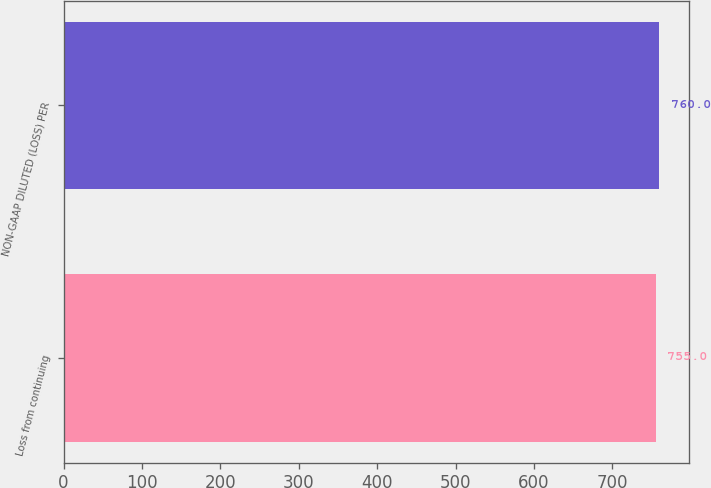Convert chart to OTSL. <chart><loc_0><loc_0><loc_500><loc_500><bar_chart><fcel>Loss from continuing<fcel>NON-GAAP DILUTED (LOSS) PER<nl><fcel>755<fcel>760<nl></chart> 